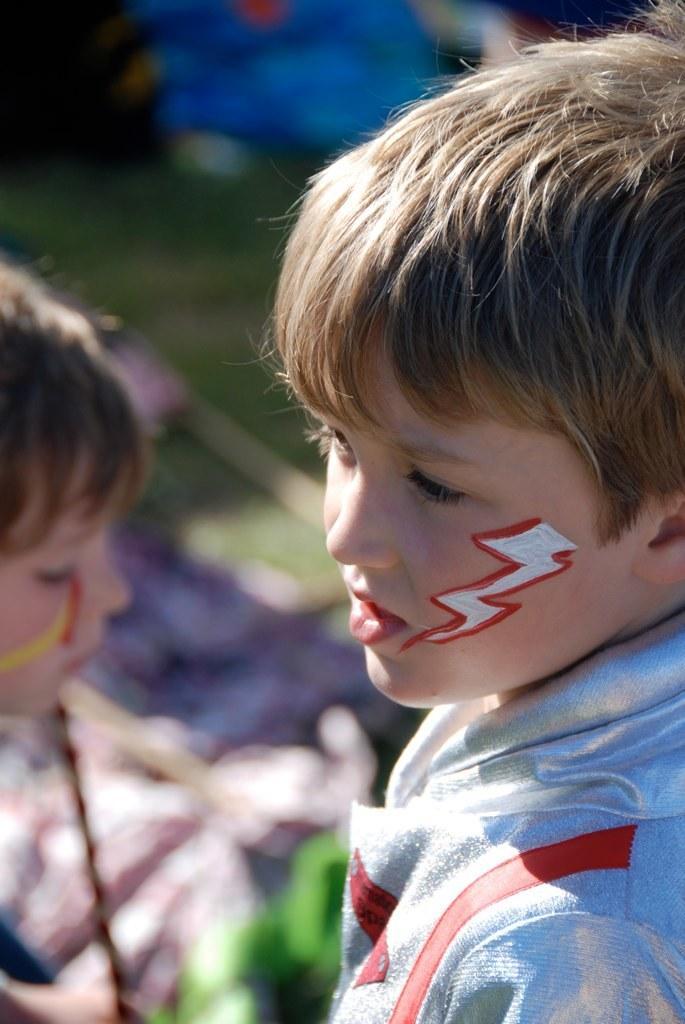Describe this image in one or two sentences. In this image in the foreground there is one boy, and in the background there is another boy and there are some objects and grass. 